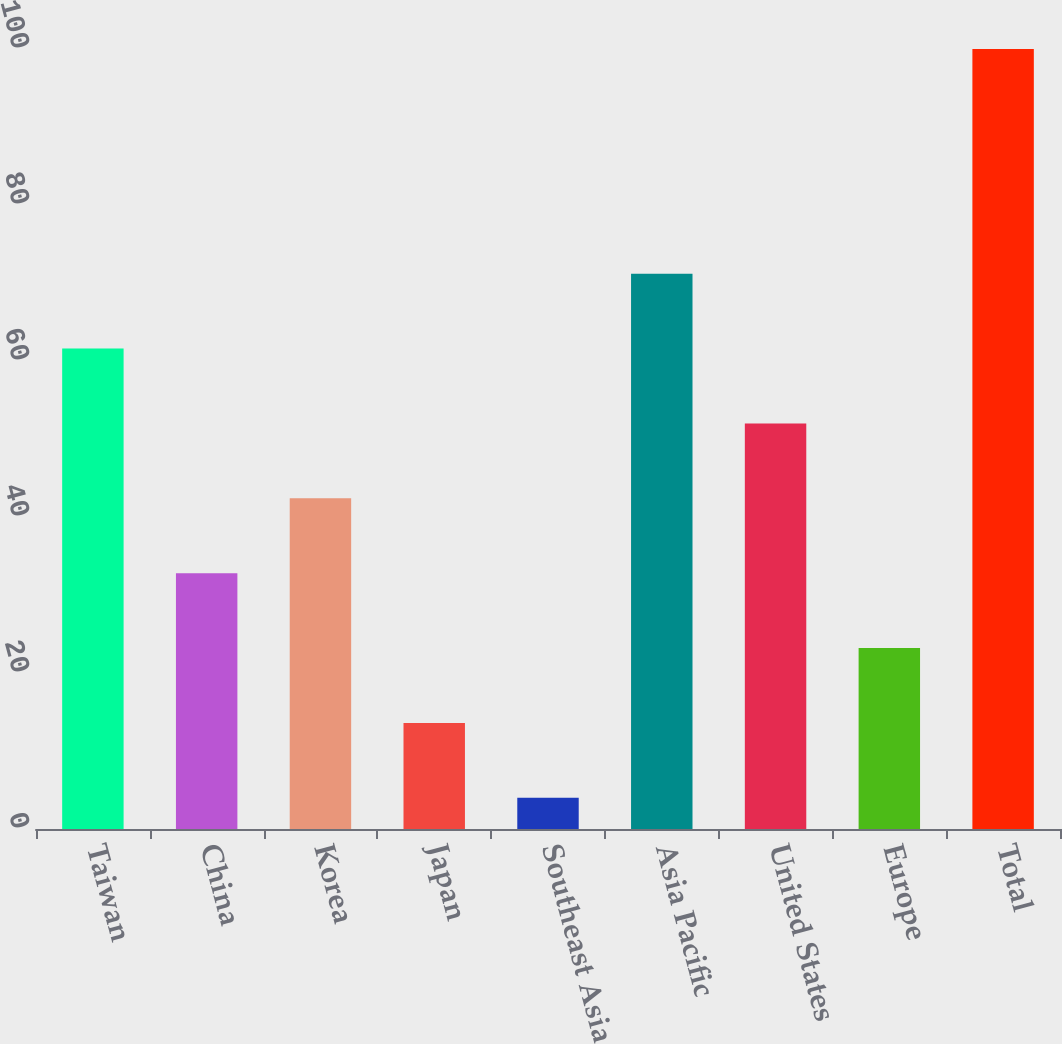Convert chart to OTSL. <chart><loc_0><loc_0><loc_500><loc_500><bar_chart><fcel>Taiwan<fcel>China<fcel>Korea<fcel>Japan<fcel>Southeast Asia<fcel>Asia Pacific<fcel>United States<fcel>Europe<fcel>Total<nl><fcel>61.6<fcel>32.8<fcel>42.4<fcel>13.6<fcel>4<fcel>71.2<fcel>52<fcel>23.2<fcel>100<nl></chart> 